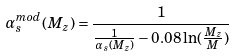<formula> <loc_0><loc_0><loc_500><loc_500>\alpha ^ { m o d } _ { s } ( M _ { z } ) = \frac { 1 } { \frac { 1 } { \alpha _ { s } ( M _ { z } ) } - 0 . 0 8 \ln ( \frac { M _ { z } } { M } ) }</formula> 